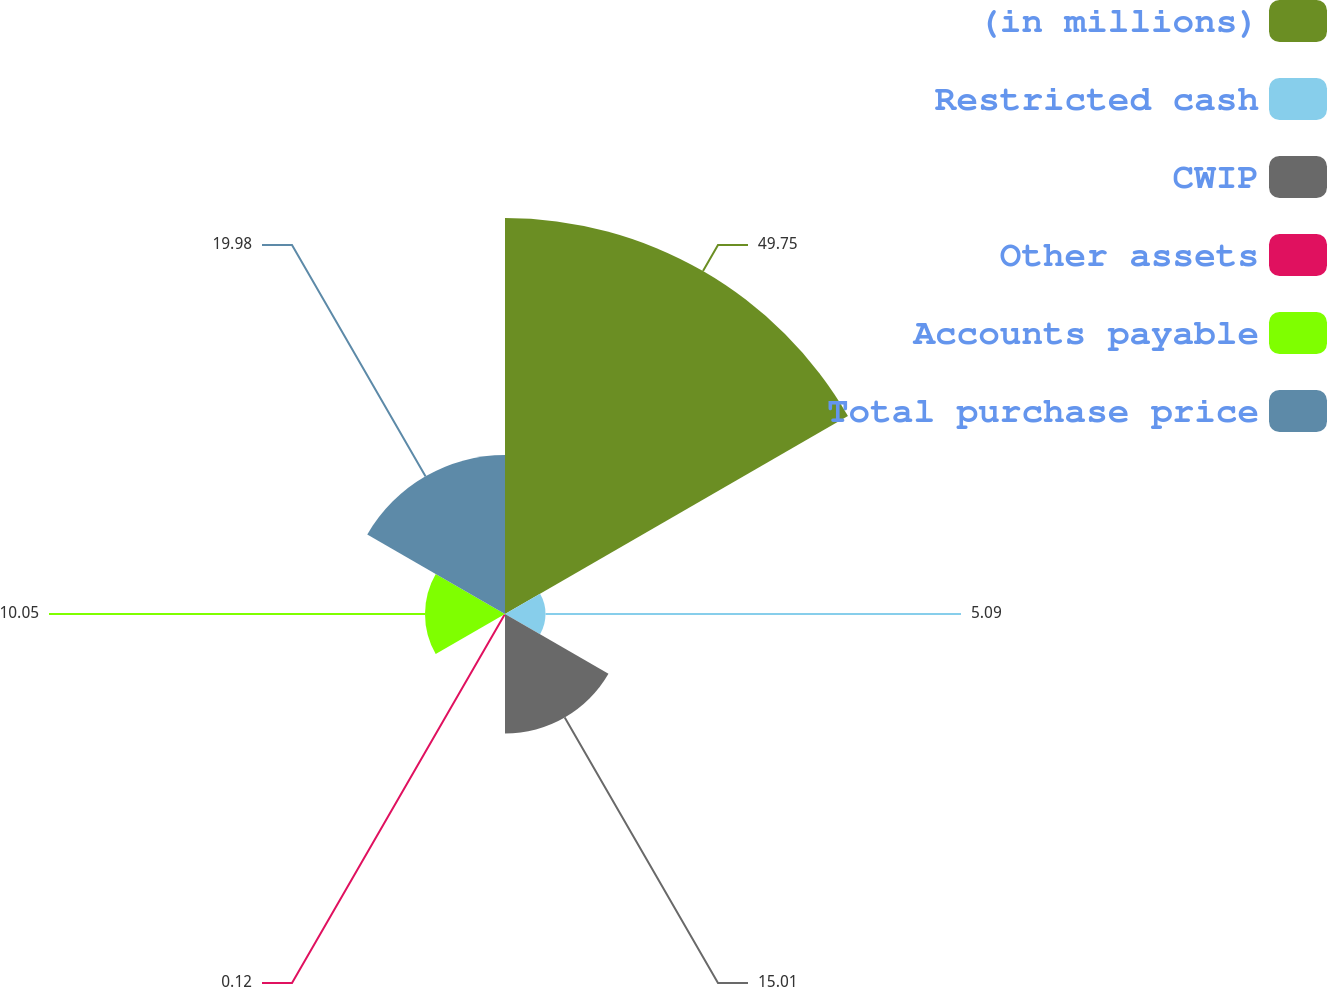Convert chart to OTSL. <chart><loc_0><loc_0><loc_500><loc_500><pie_chart><fcel>(in millions)<fcel>Restricted cash<fcel>CWIP<fcel>Other assets<fcel>Accounts payable<fcel>Total purchase price<nl><fcel>49.75%<fcel>5.09%<fcel>15.01%<fcel>0.12%<fcel>10.05%<fcel>19.98%<nl></chart> 